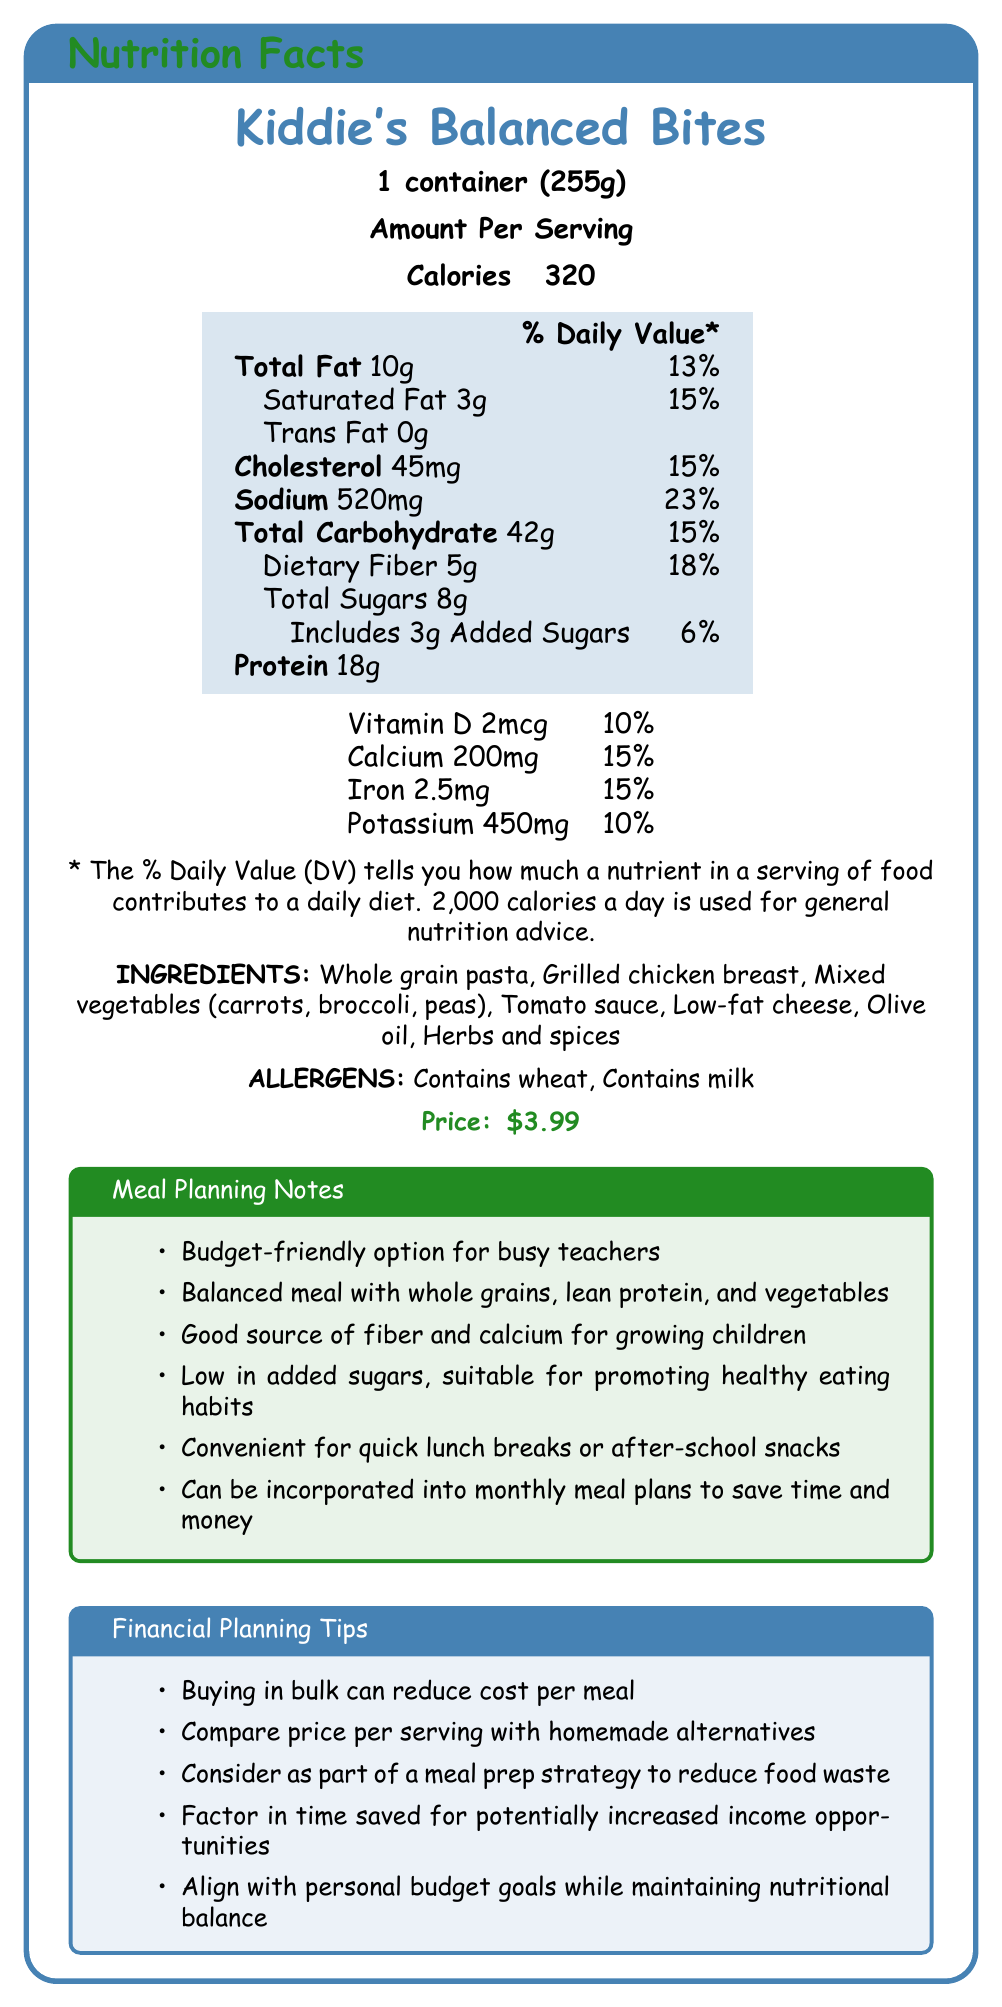What is the serving size of Kiddie's Balanced Bites? The document states that the serving size is 1 container (255g).
Answer: 1 container (255g) How many calories are in one serving of Kiddie's Balanced Bites? The document lists the calorie count per serving as 320.
Answer: 320 What is the total fat content per serving, and what percentage of the daily value does it represent? The document provides this information directly, stating that there are 10g of total fat per serving, which is 13% of the daily value.
Answer: 10g, 13% What are the main ingredients in Kiddie's Balanced Bites? The list of ingredients is clearly provided in the document.
Answer: Whole grain pasta, Grilled chicken breast, Mixed vegetables (carrots, broccoli, peas), Tomato sauce, Low-fat cheese, Olive oil, Herbs and spices What allergens are present in Kiddie's Balanced Bites? The document lists the allergens as "Contains wheat" and "Contains milk."
Answer: Contains wheat, Contains milk Based on the document, which of the following most accurately describes the purpose of the meal planning notes section? A. To list the ingredients B. To detail the nutritional content C. To provide usage tips for meal planning D. To highlight the allergens The meal planning notes provide tips for using Kiddie's Balanced Bites in meal planning.
Answer: C Which nutrient has the highest daily value percentage in Kiddie's Balanced Bites? A. Sodium B. Dietary Fiber C. Total Fat D. Added Sugars Sodium has the highest daily value percentage at 23%.
Answer: A Is Kiddie's Balanced Bites a budget-friendly option? The document mentions that it is a budget-friendly option for busy teachers.
Answer: Yes Summarize the main ideas presented in the document. The summary covers the comprehensive information given in the document relating to nutritional value, cost, and practical usage tips.
Answer: The document provides the nutritional facts, ingredients, allergens, price, and various notes on meal and financial planning for Kiddie's Balanced Bites. It emphasizes the convenience, budget-friendliness, and balanced nutritional profile of the meal. How much dietary fiber is in one serving? The document states that there are 5g of dietary fiber per serving.
Answer: 5g What is the price of one container of Kiddie's Balanced Bites? The price listed in the document is $3.99.
Answer: $3.99 Does Kiddie's Balanced Bites contain any trans fat? The document indicates that there is 0g of trans fat in the product.
Answer: No How can buying Kiddie's Balanced Bites in bulk affect its cost per meal? The financial planning tips suggest that buying in bulk can reduce the cost per meal.
Answer: Reduce cost per meal What specific food groups are combined in Kiddie's Balanced Bites to make it a balanced meal? The meal planning notes indicate that the meal includes whole grains, lean protein, and vegetables to make it a balanced meal.
Answer: Whole grains, Lean protein, Vegetables Can we determine the exact amount of tomato sauce used in Kiddie's Balanced Bites from the document? The document lists the ingredients but does not specify the exact amount of tomato sauce used.
Answer: Cannot be determined 